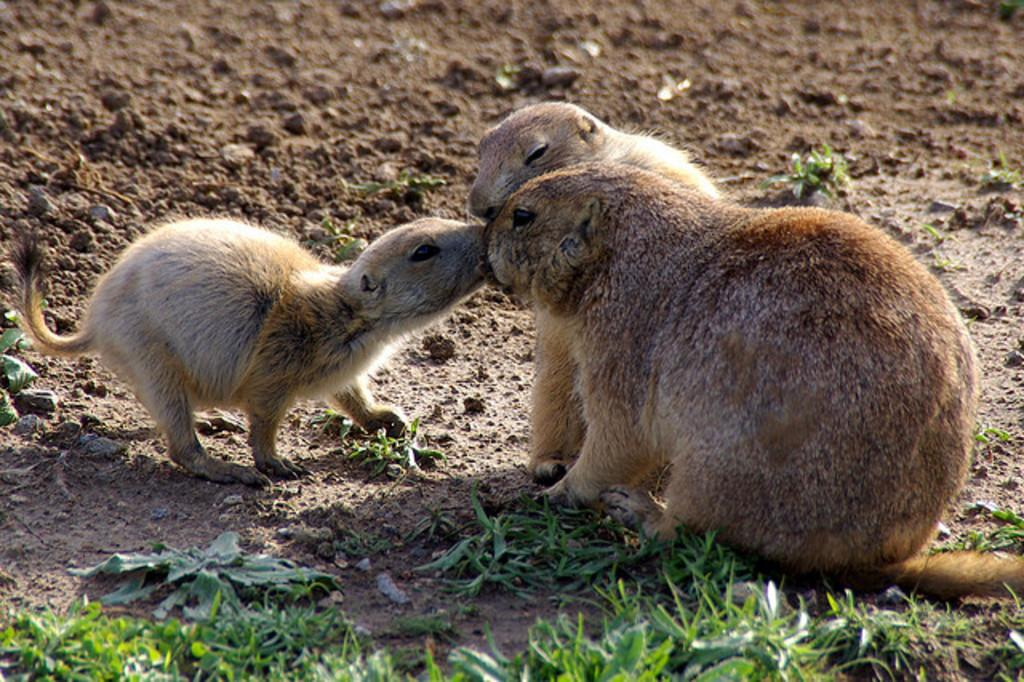What is located in the center of the image? There are animals in the center of the image. What type of vegetation can be seen on the ground in the image? There is grass on the ground in the front of the image. What type of sponge is being used to clean the animals in the image? There is no sponge present in the image, and the animals are not being cleaned. 